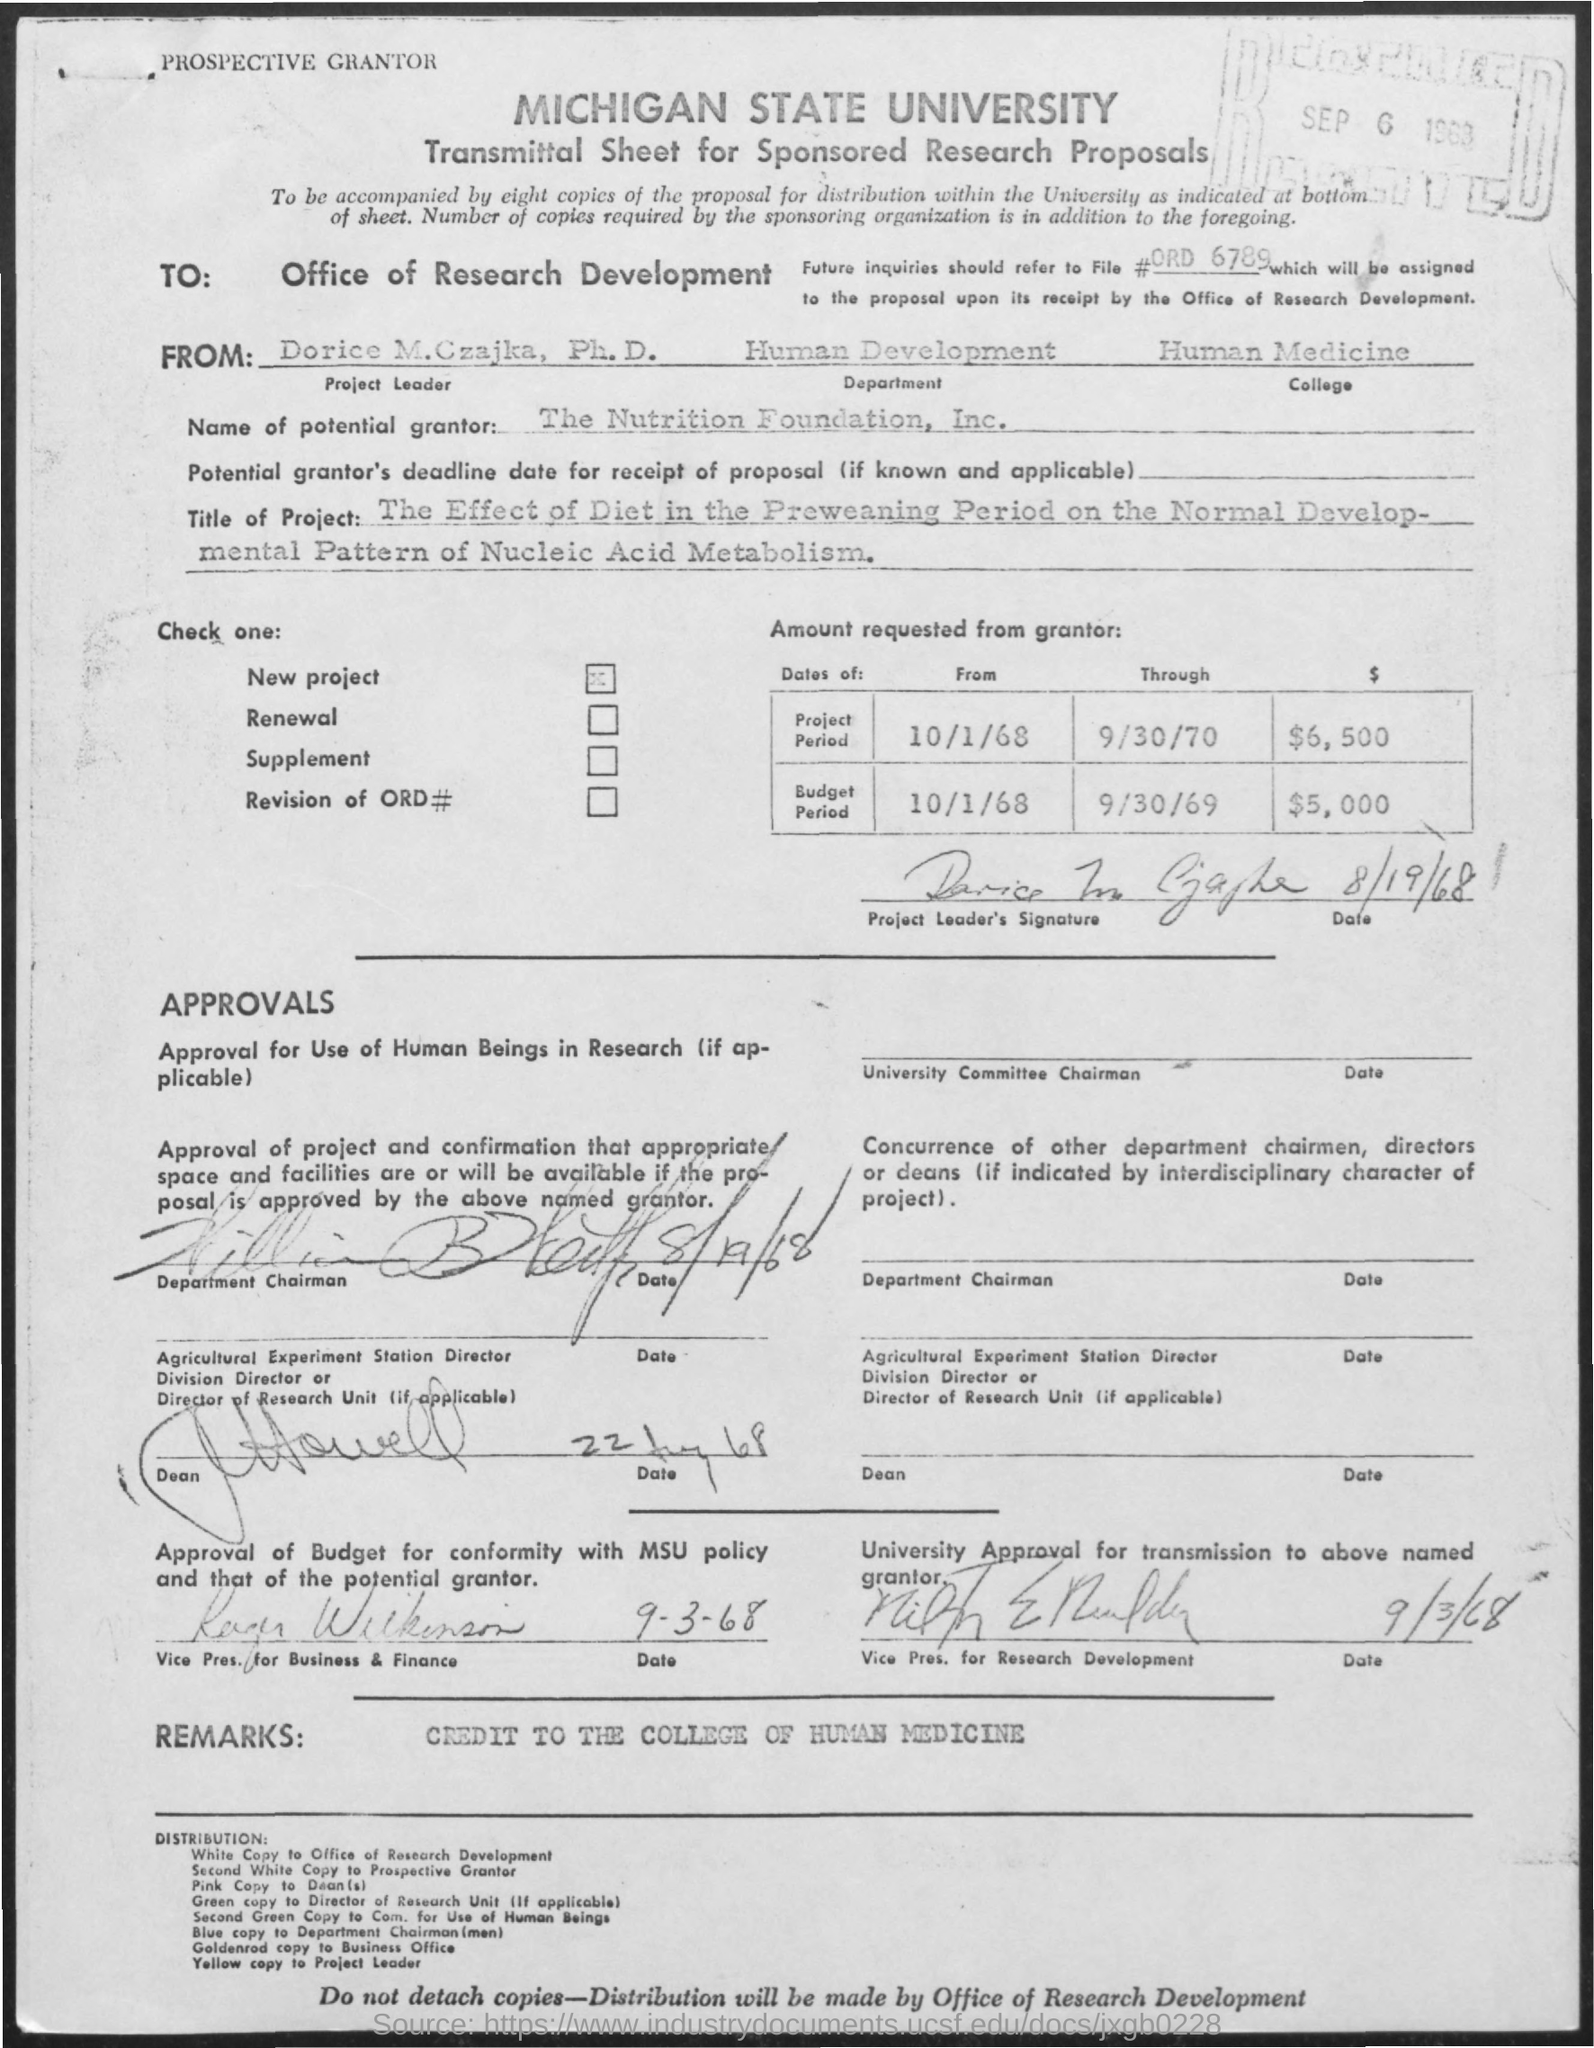Mention a couple of crucial points in this snapshot. The Michigan State University is named in the given form. The college name mentioned is Human Medicine. The department mentioned is Human Development. The name of the project leader mentioned is Dorice M. Czajka. The title of the project described in the given form is "THE EFFECT OF DIET IN THE PREWEANING PERIOD ON THE NORMAL DEVELOPMENTAL PATTERN OF NUCLEIC ACID METABOLISM. 